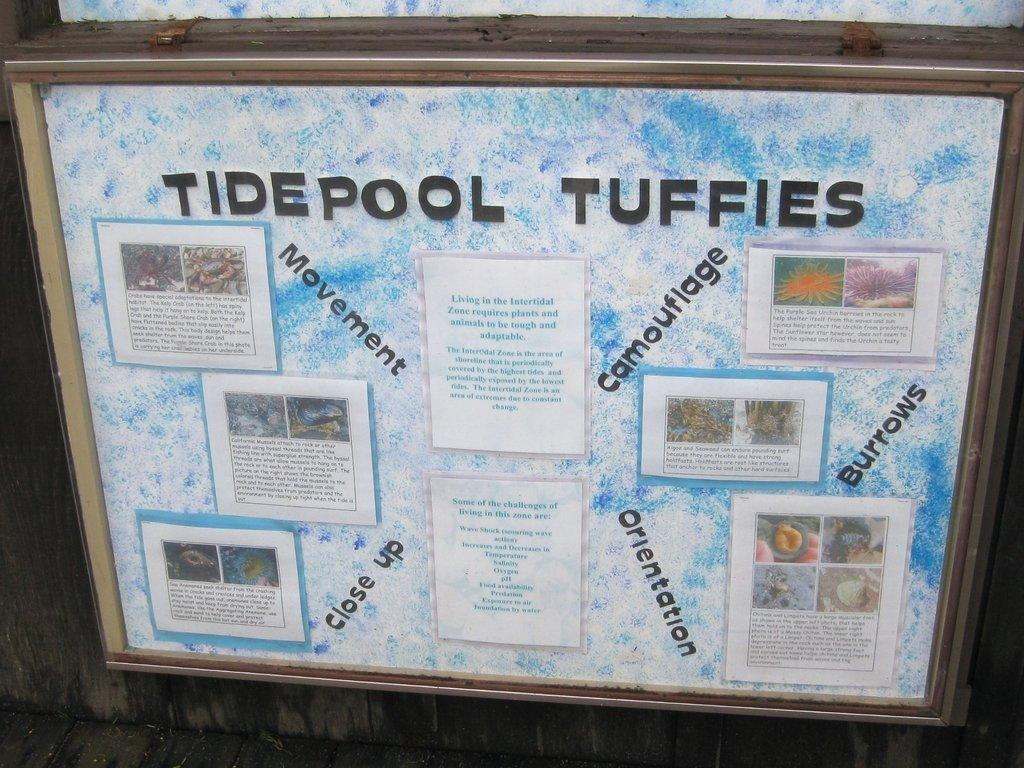Provide a one-sentence caption for the provided image. An informational display of Tidepool Tuffies featuring five sections. 